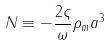Convert formula to latex. <formula><loc_0><loc_0><loc_500><loc_500>N \equiv - \frac { 2 \varsigma } { \omega } \rho _ { m } a ^ { 3 }</formula> 